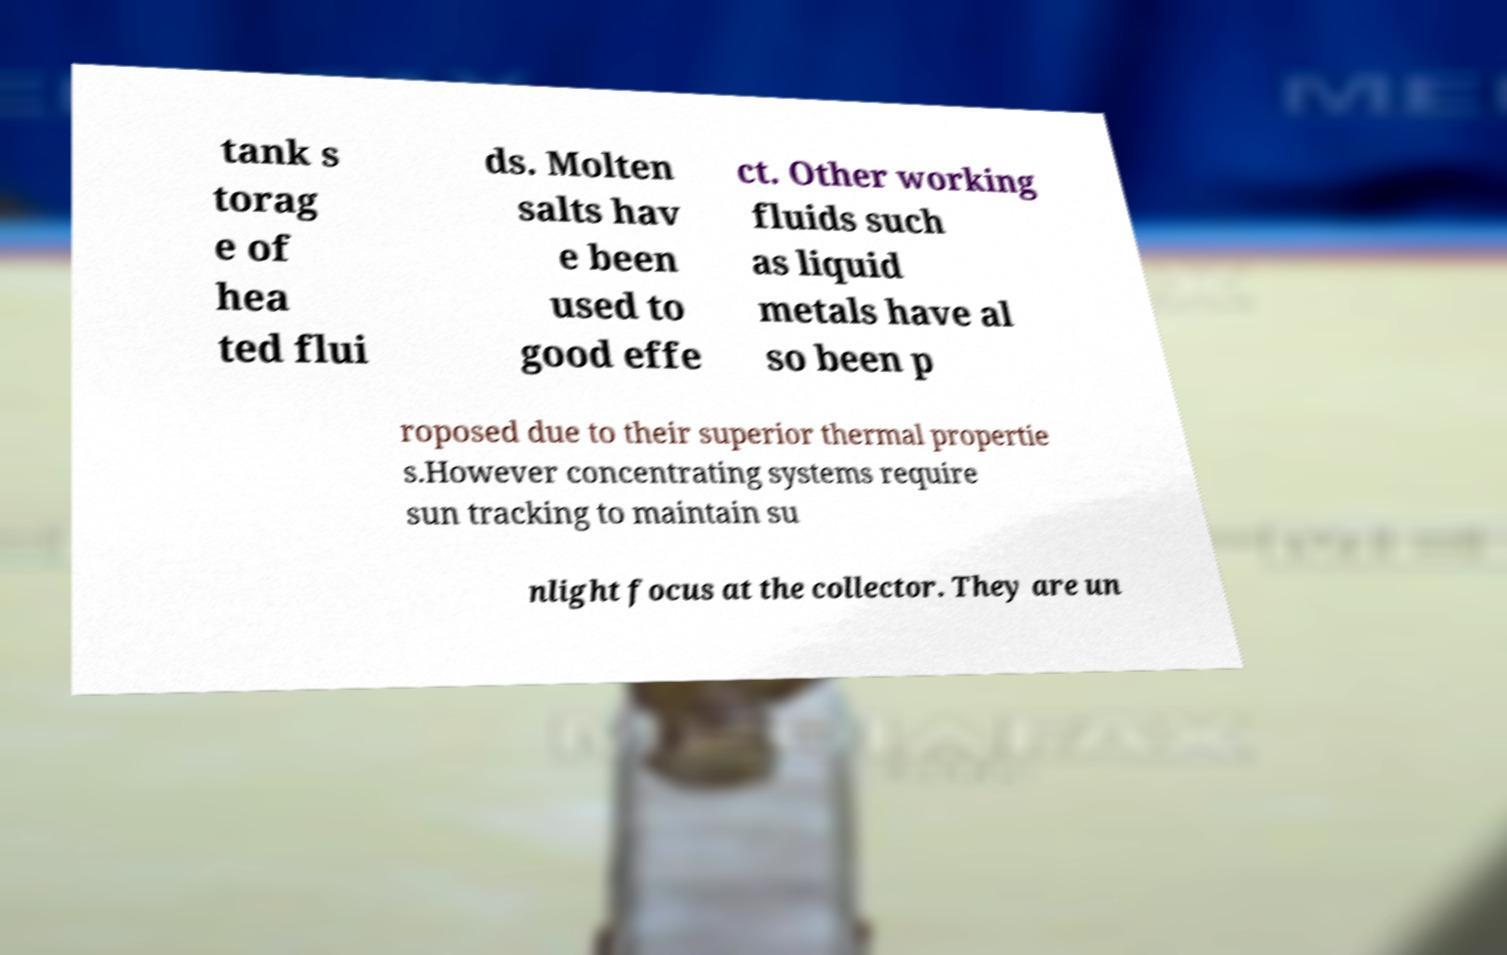What messages or text are displayed in this image? I need them in a readable, typed format. tank s torag e of hea ted flui ds. Molten salts hav e been used to good effe ct. Other working fluids such as liquid metals have al so been p roposed due to their superior thermal propertie s.However concentrating systems require sun tracking to maintain su nlight focus at the collector. They are un 